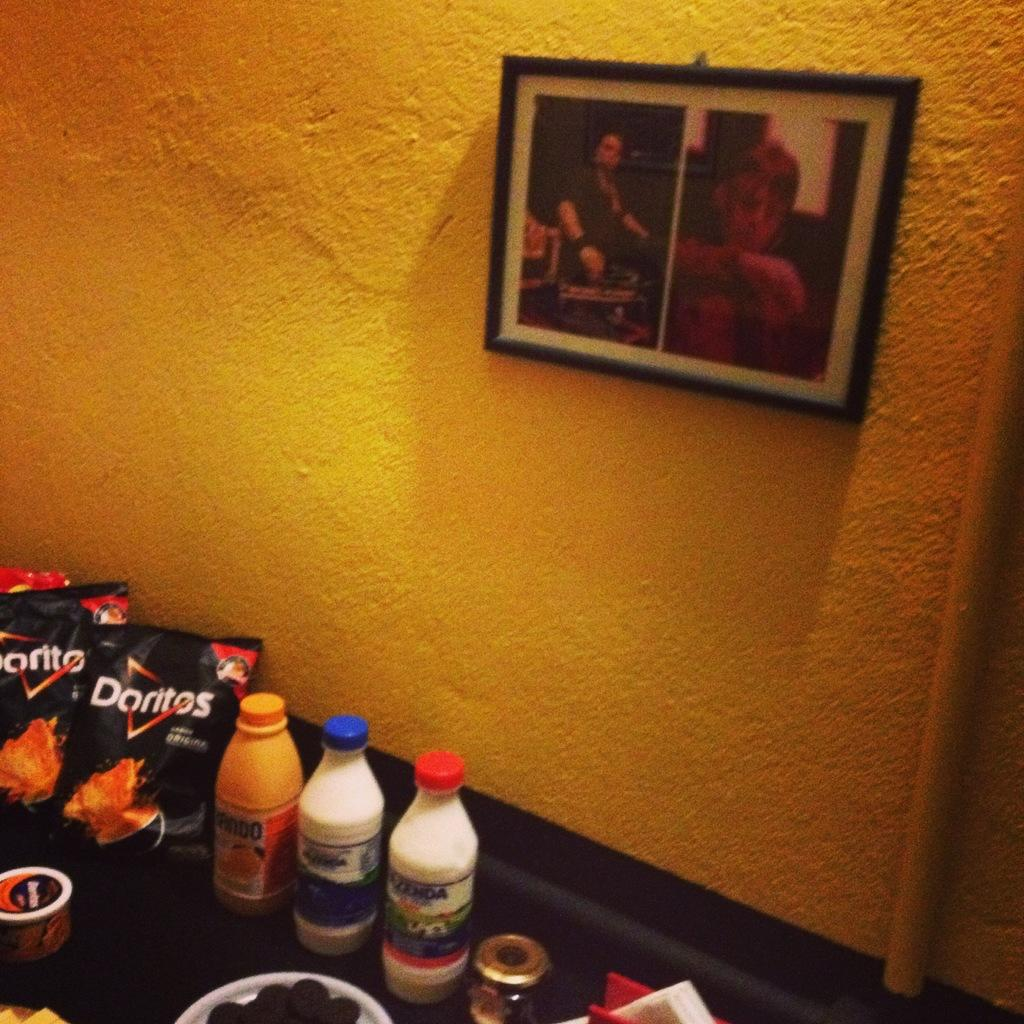Provide a one-sentence caption for the provided image. Bags of Doritos chips are displayed next to beverages on a table in front of a yellow wall. 